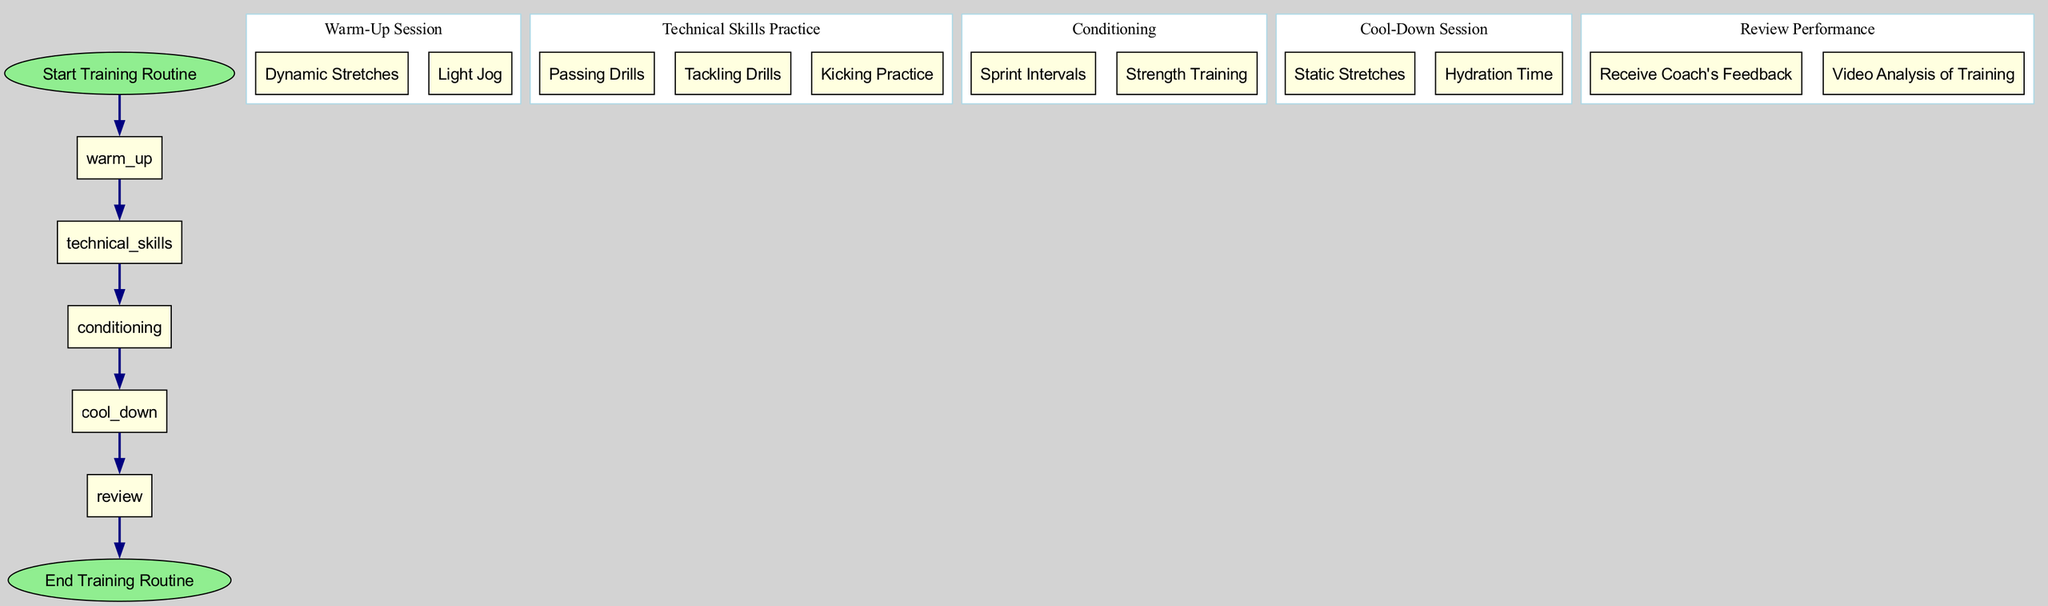What is the first activity in the training routine? The diagram starts with the node labeled "Start Training Routine," which indicates the first step in the training process.
Answer: Start Training Routine How many action items are there under Technical Skills Practice? Under the "Technical Skills Practice" node, there are three action items listed: "Passing Drills," "Tackling Drills," and "Kicking Practice." Thus, the total is three.
Answer: 3 What activity follows the Warm-Up Session? The diagram shows a directed edge leading from the "Warm-Up Session" node to the "Technical Skills Practice" node, indicating that Technical Skills Practice comes next after Warm-Up.
Answer: Technical Skills Practice Which activity is the last before the end of the routine? The "Review Performance" node is the last activity before transitioning to the "End Training Routine." This is indicated by the arrow leading to the end activity.
Answer: Review Performance How many nodes are there in total in the training routine? There are six primary nodes in the activity diagram: "Start Training Routine," "Warm-Up Session," "Technical Skills Practice," "Conditioning," "Cool-Down Session," and "End Training Routine." Therefore, the total count is six.
Answer: 6 What action follows Strength Training in the process? The diagram illustrates a transition from the "Conditioning" activity, which includes "Strength Training," to the "Cool-Down Session" activity. Thus, the action that follows is the Cool-Down Session.
Answer: Cool-Down Session What type of analysis is conducted during the Review Performance phase? One of the actions listed under "Review Performance" is "Video Analysis of Training," which indicates that video analysis is a component of this review phase.
Answer: Video Analysis of Training How many transitions are there in the training routine? The diagram contains six transitions connecting the activities, detailing the flow from start to end.
Answer: 6 Which action is taken during the Cool-Down Session? The "Cool-Down Session" includes two actions: "Static Stretches" and "Hydration Time." Thus, both actions are part of this session.
Answer: Static Stretches, Hydration Time 